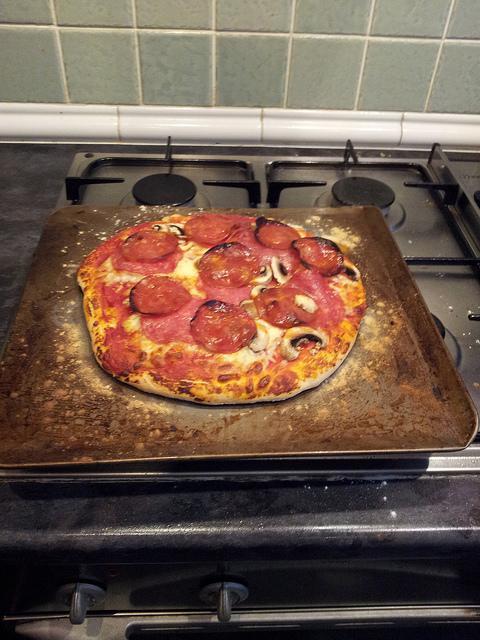Evaluate: Does the caption "The pizza is on top of the oven." match the image?
Answer yes or no. Yes. 